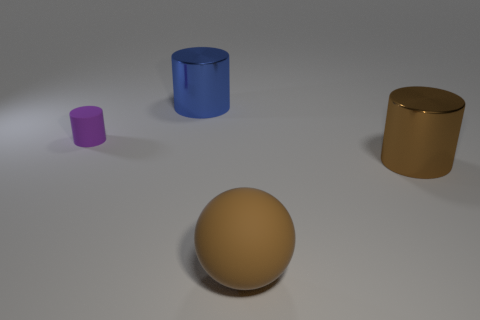What number of things are on the left side of the large cylinder that is behind the large cylinder in front of the small rubber object?
Ensure brevity in your answer.  1. There is a big matte ball; are there any big objects on the left side of it?
Your response must be concise. Yes. How many other big objects are the same material as the large blue object?
Ensure brevity in your answer.  1. What number of objects are either tiny purple cylinders or matte spheres?
Give a very brief answer. 2. Are any blue shiny cylinders visible?
Your response must be concise. Yes. The large cylinder that is left of the big cylinder on the right side of the shiny cylinder that is on the left side of the big brown rubber ball is made of what material?
Give a very brief answer. Metal. Is the number of shiny cylinders in front of the tiny purple matte thing less than the number of tiny gray objects?
Offer a terse response. No. There is a sphere that is the same size as the brown shiny thing; what is its material?
Your answer should be compact. Rubber. There is a cylinder that is in front of the blue shiny object and left of the big brown metallic cylinder; what is its size?
Make the answer very short. Small. There is a rubber thing that is the same shape as the large blue metallic object; what size is it?
Your answer should be very brief. Small. 